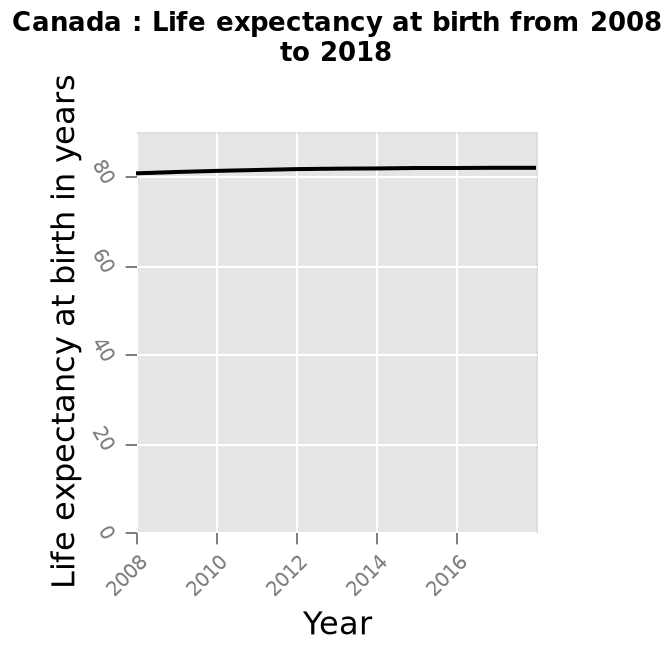<image>
please summary the statistics and relations of the chart There is almost no change in life expectancy over time. Life expectancy is above 80 over the whole x-axis range on the line graph plot (tick for 2018 is missing though). There is a minimal increase in life expectancy between 2008 and 2012, perhaps 1 or 2 years. 